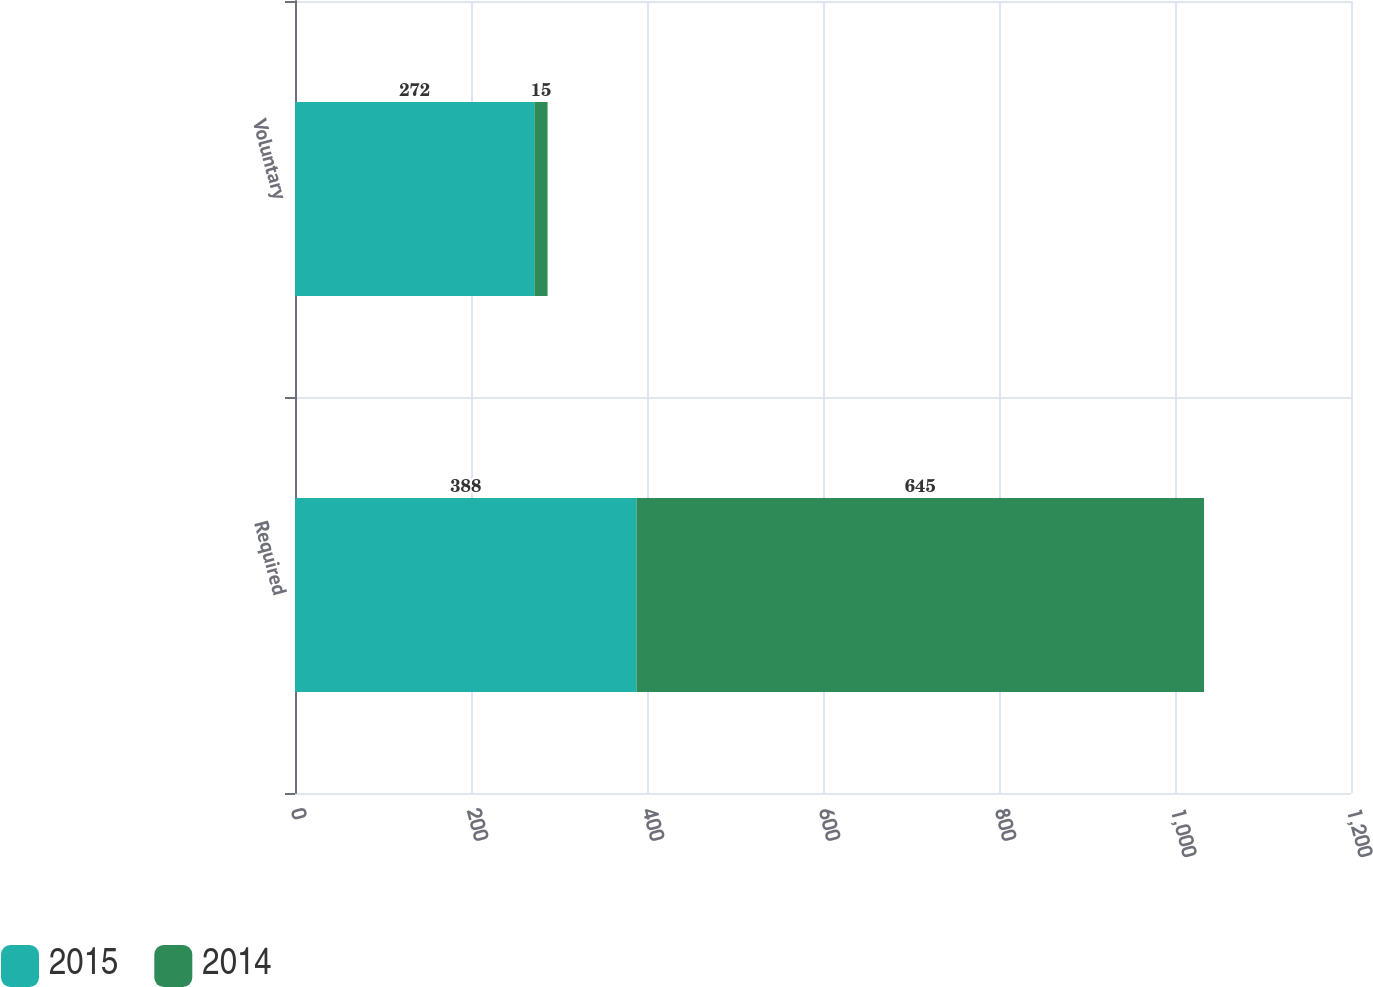Convert chart. <chart><loc_0><loc_0><loc_500><loc_500><stacked_bar_chart><ecel><fcel>Required<fcel>Voluntary<nl><fcel>2015<fcel>388<fcel>272<nl><fcel>2014<fcel>645<fcel>15<nl></chart> 